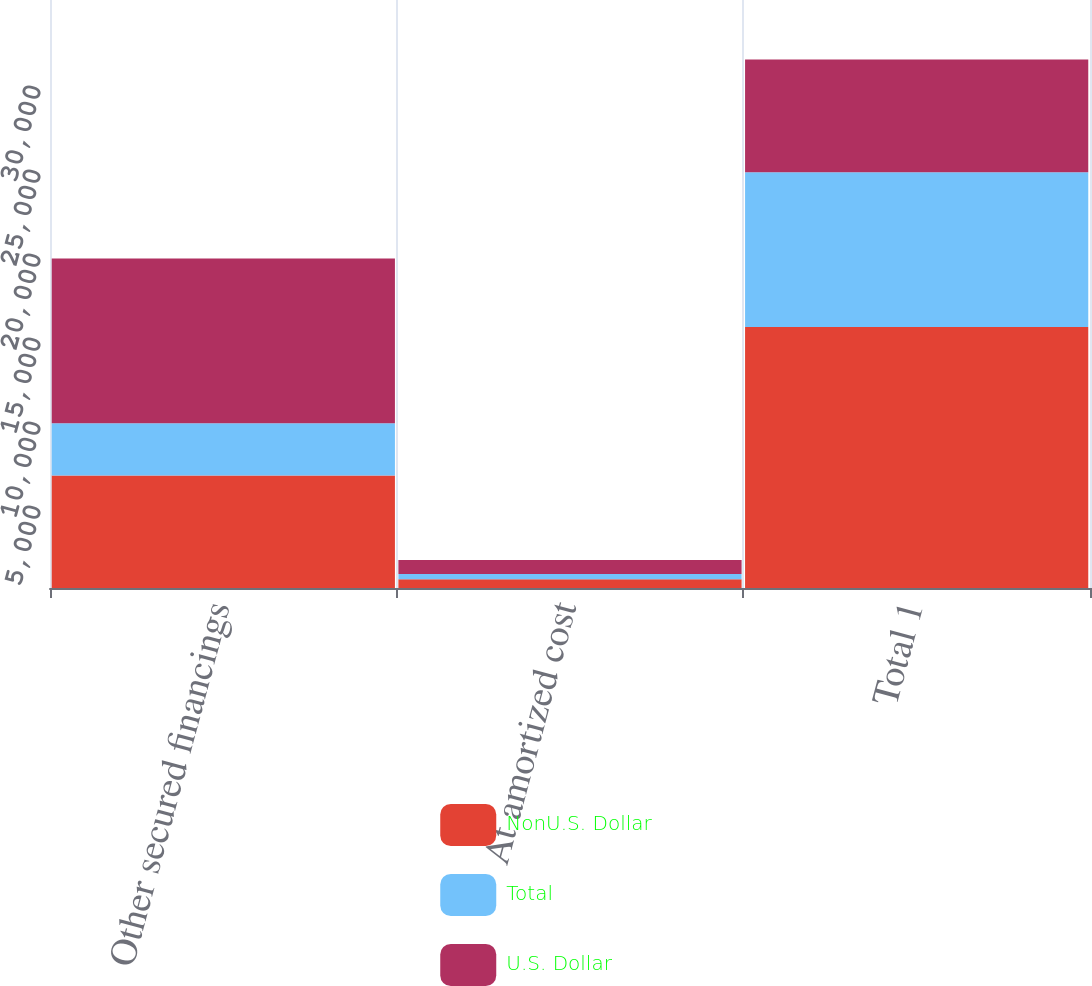Convert chart. <chart><loc_0><loc_0><loc_500><loc_500><stacked_bar_chart><ecel><fcel>Other secured financings<fcel>At amortized cost<fcel>Total 1<nl><fcel>NonU.S. Dollar<fcel>6702<fcel>514<fcel>15538<nl><fcel>Total<fcel>3105<fcel>319<fcel>9215<nl><fcel>U.S. Dollar<fcel>9807<fcel>833<fcel>6702<nl></chart> 